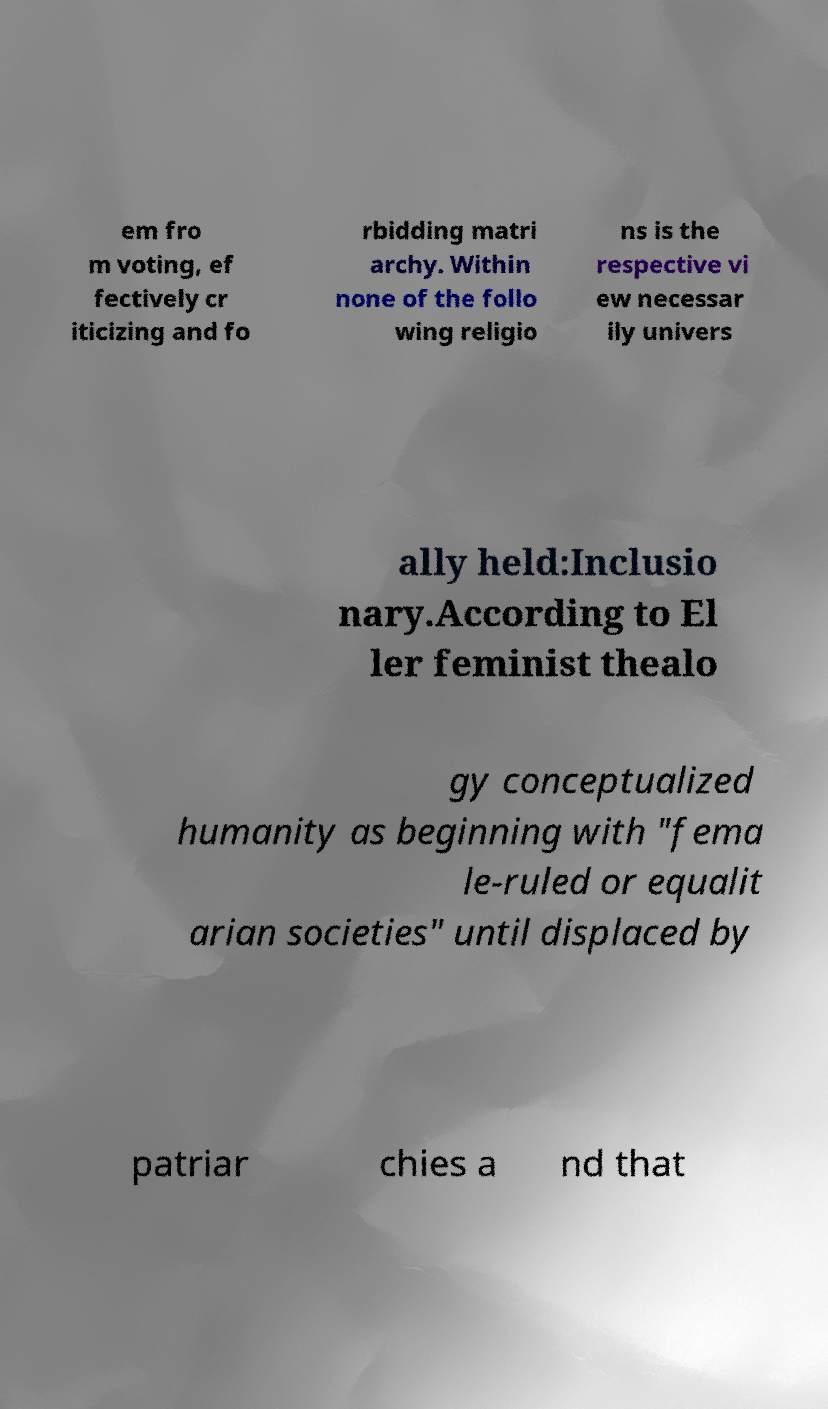For documentation purposes, I need the text within this image transcribed. Could you provide that? em fro m voting, ef fectively cr iticizing and fo rbidding matri archy. Within none of the follo wing religio ns is the respective vi ew necessar ily univers ally held:Inclusio nary.According to El ler feminist thealo gy conceptualized humanity as beginning with "fema le-ruled or equalit arian societies" until displaced by patriar chies a nd that 